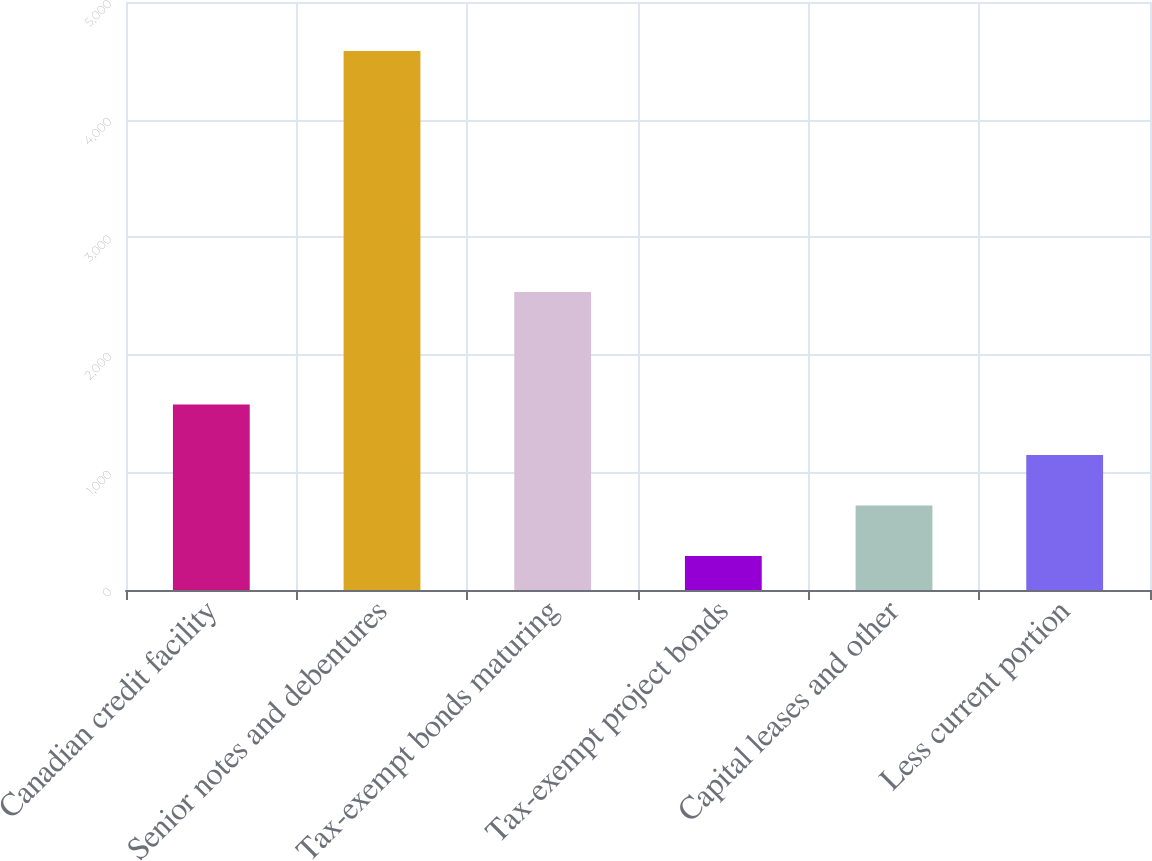<chart> <loc_0><loc_0><loc_500><loc_500><bar_chart><fcel>Canadian credit facility<fcel>Senior notes and debentures<fcel>Tax-exempt bonds maturing<fcel>Tax-exempt project bonds<fcel>Capital leases and other<fcel>Less current portion<nl><fcel>1578.2<fcel>4584<fcel>2533<fcel>290<fcel>719.4<fcel>1148.8<nl></chart> 